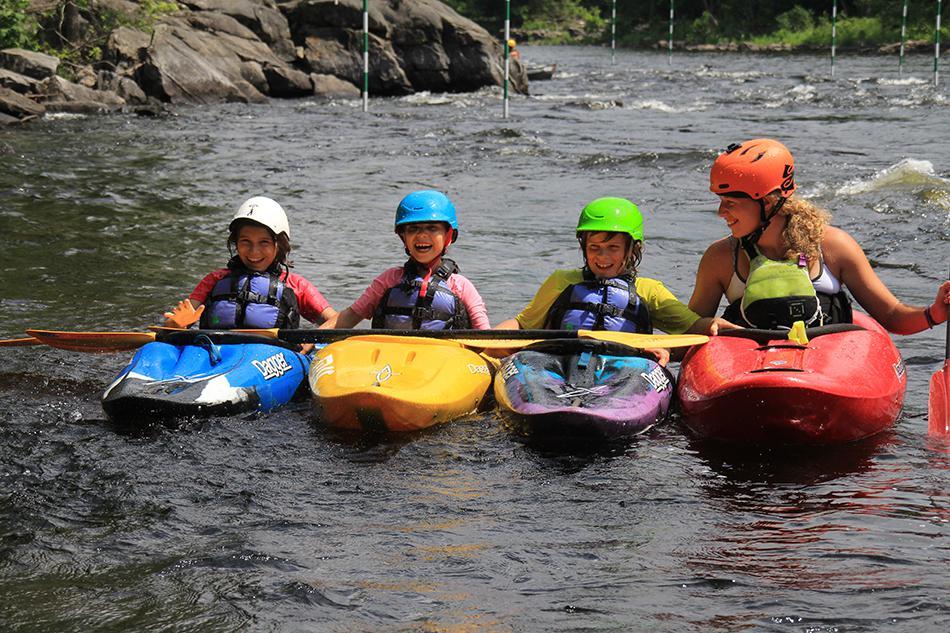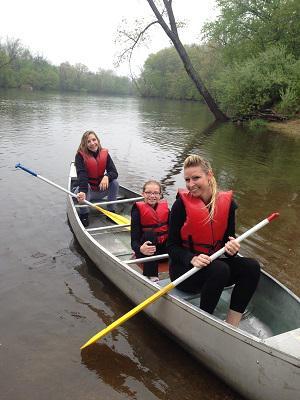The first image is the image on the left, the second image is the image on the right. Assess this claim about the two images: "A red boat is in the water in the image on the left.". Correct or not? Answer yes or no. Yes. The first image is the image on the left, the second image is the image on the right. Evaluate the accuracy of this statement regarding the images: "Right image shows a canoe holding three people who all wear red life vests.". Is it true? Answer yes or no. Yes. 